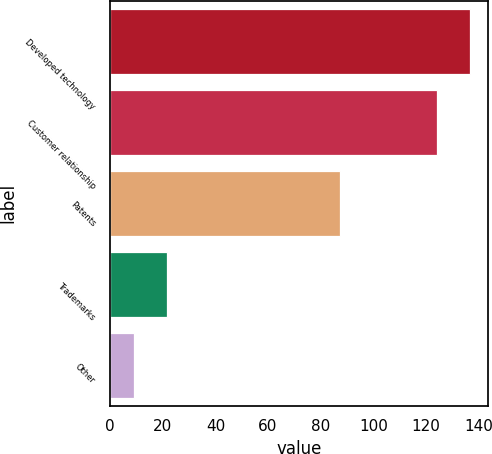Convert chart to OTSL. <chart><loc_0><loc_0><loc_500><loc_500><bar_chart><fcel>Developed technology<fcel>Customer relationship<fcel>Patents<fcel>Trademarks<fcel>Other<nl><fcel>136.55<fcel>124.2<fcel>87.2<fcel>21.55<fcel>9.2<nl></chart> 